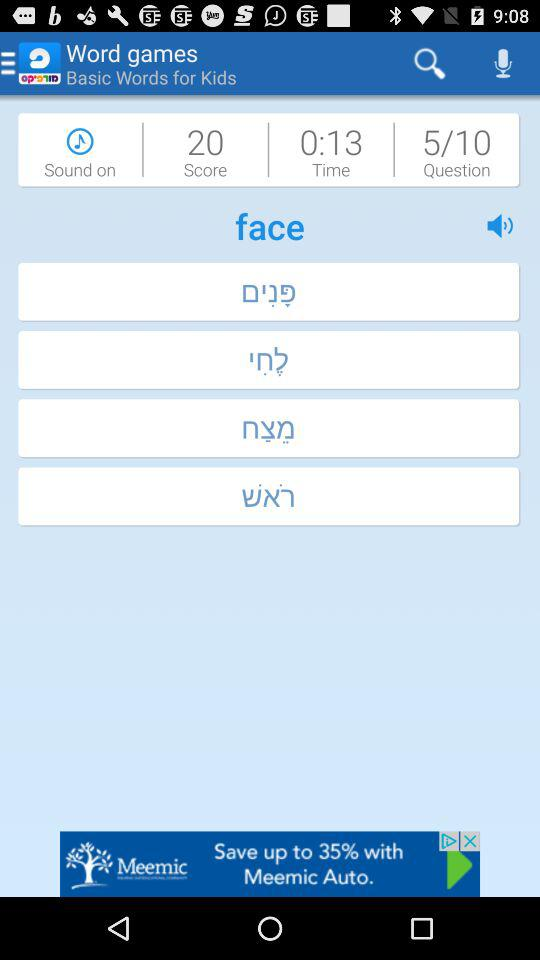What is the "Sound" status? The "Sound" status is "on". 